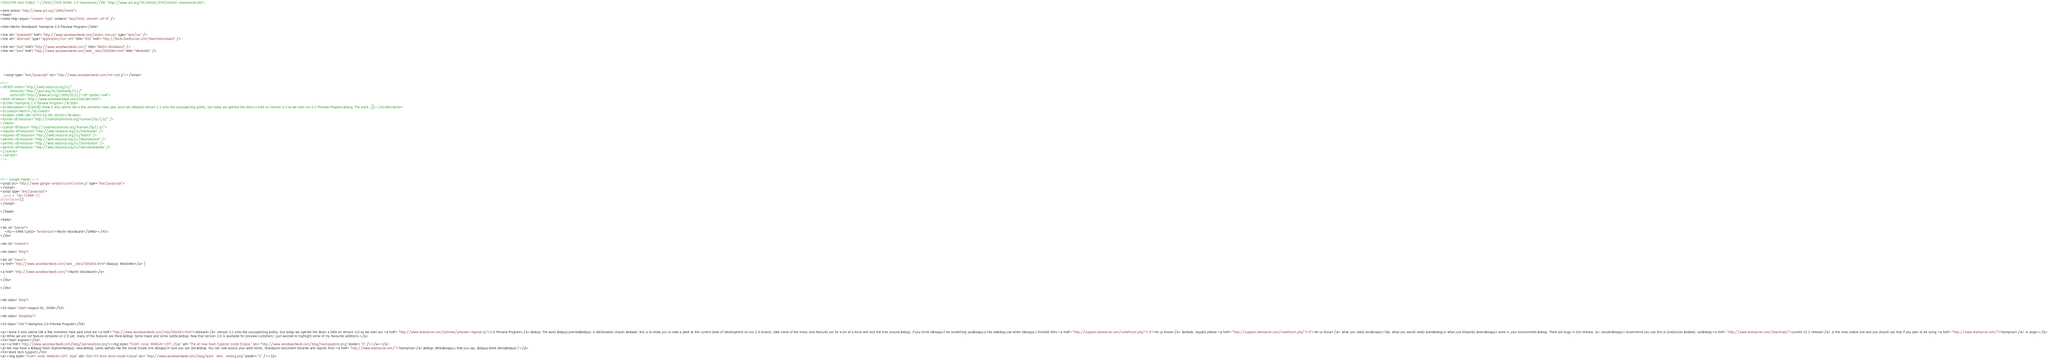<code> <loc_0><loc_0><loc_500><loc_500><_HTML_><!DOCTYPE html PUBLIC "-//W3C//DTD XHTML 1.0 Transitional//EN" "http://www.w3.org/TR/xhtml1/DTD/xhtml1-transitional.dtd">

<html xmlns="http://www.w3.org/1999/xhtml">
<head>
<meta http-equiv="Content-Type" content="text/html; charset=utf-8" />

<title>Martin Woodward: Teamprise 2.0 Preview Program</title>

<link rel="stylesheet" href="http://www.woodwardweb.com/styles-site.css" type="text/css" />
<link rel="alternate" type="application/rss+xml" title="RSS" href="http://feeds.feedburner.com/MartinWoodward" />

<link rel="start" href="http://www.woodwardweb.com/" title="Martin Woodward" />
<link rel="prev" href="http://www.woodwardweb.com/web_sites/000264.html" title="MeeboMe" />





   <script type="text/javascript" src="http://www.woodwardweb.com/mt-site.js"></script>

<!--
<rdf:RDF xmlns="http://web.resource.org/cc/"
         xmlns:dc="http://purl.org/dc/elements/1.1/"
         xmlns:rdf="http://www.w3.org/1999/02/22-rdf-syntax-ns#">
<Work rdf:about="http://www.woodwardweb.com/000265.html">
<dc:title>Teamprise 2.0 Preview Program</dc:title>
<dc:description><![CDATA[I know it only seems like a few moments have past since we released version 1.1 onto the unsuspecting public, but today we opened the doors a little on Version 2.0 as we start our 2.0 Preview Program.&nbsp; The word...]]></dc:description>
<dc:creator>Martin</dc:creator>
<dc:date>2006-08-03T22:52:26+00:00</dc:date>
<license rdf:resource="http://creativecommons.org/licenses/by/1.0/" />
</Work>
<License rdf:about="http://creativecommons.org/licenses/by/1.0/">
<requires rdf:resource="http://web.resource.org/cc/Attribution" />
<requires rdf:resource="http://web.resource.org/cc/Notice" />
<permits rdf:resource="http://web.resource.org/cc/Reproduction" />
<permits rdf:resource="http://web.resource.org/cc/Distribution" />
<permits rdf:resource="http://web.resource.org/cc/DerivativeWorks" />
</License>
</rdf:RDF>
-->




<!-- Google tracker -->
<script src="http://www.google-analytics.com/urchin.js" type="text/javascript">
</script>
<script type="text/javascript">
_uacct = "UA-71966-1";
urchinTracker();
</script>

</head>

<body>

<div id="banner">
	<H1><SPAN CLASS="textVersion">Martin Woodward</SPAN></H1>
</div>

<div id="content">

<div class="blog">

<div id="menu">
<a href="http://www.woodwardweb.com/web_sites/000264.html">&laquo; MeeboMe</a> |

<a href="http://www.woodwardweb.com/">Martin Woodward</a>

</div>

</div>


<div class="blog">

<h2 class="date">August 03, 2006</h2>

<div class="blogbody">

<h3 class="title">Teamprise 2.0 Preview Program</h3>

<p>I know it only seems like a few moments have past since we <a href="http://www.woodwardweb.com/vsts/000261.html">released</a> version 1.1 onto the unsuspecting public, but today we opened the doors a little on Version 2.0 as we start our <a href="http://www.teamprise.com/preview/preview-register.py">2.0 Preview Program</a>.&nbsp; The word &ldquo;preview&rdquo; is deliberately chosen &ndash; this is to allow you to take a peek at the current state of development on our 2.0 branch, take some of the many new features out for a bit of a drive and kick the tires around.&nbsp; If you think it&rsquo;ll be something you&rsquo;d like to&nbsp;use when it&rsquo;s finished then <a href="http://support.teamprise.com/viewforum.php?f=6">let us know</a> &ndash; equally please <a href="http://support.teamprise.com/viewforum.php?f=6">let us know</a> what you really don&rsquo;t like, what you would really want&nbsp;or what just blatantly doesn&rsquo;t work in your environment.&nbsp; There are bugs in this release, so I wouldn&rsquo;t recommend you use this in production &ndash; our&nbsp;<a href="http://www.teamprise.com/download/">current V1.1 release</a> is the most stable one and you should use that if you plan to be using <a href="http://www.teamprise.com/">Teamprise</a> in anger.</p>
<p>While we are not feature complete on 2.0 yet, many of the features are there.&nbsp; Some major and some subtle.&nbsp; Now that Version 2.0 is available for preview customers I just wanted to highlight some of my favourite additions.</p>
<h3>Team Explorer</h3>
<p><a href="http://www.woodwardweb.com/blog/teamexplorer.png"><img style="FLOAT: none; MARGIN-LEFT: 25px" alt="The all new Team Explorer inside Eclipse." src="http://www.woodwardweb.com/blog/teamexplorer.png" border="0" /></a></p>
<p>We now have a &ldquo;Team Explorer&rdquo; view.&nbsp; Looks awfully like the Visual Studio one I&rsquo;m sure you can see.&nbsp; You can now access your work items, Sharepoint document libraries and reports from <a href="http://www.teamprise.com/">Teamprise</a>.&nbsp; What&rsquo;s that you say, &ldquo;Work Items&rdquo;?</p>
<h3>Work Item Support</h3>
<p><img style="FLOAT: none; MARGIN-LEFT: 25px" alt="Edit TFS Work Items inside Eclipse" src="http://www.woodwardweb.com/blog/work_item_editing.png" border="0" /></p></code> 